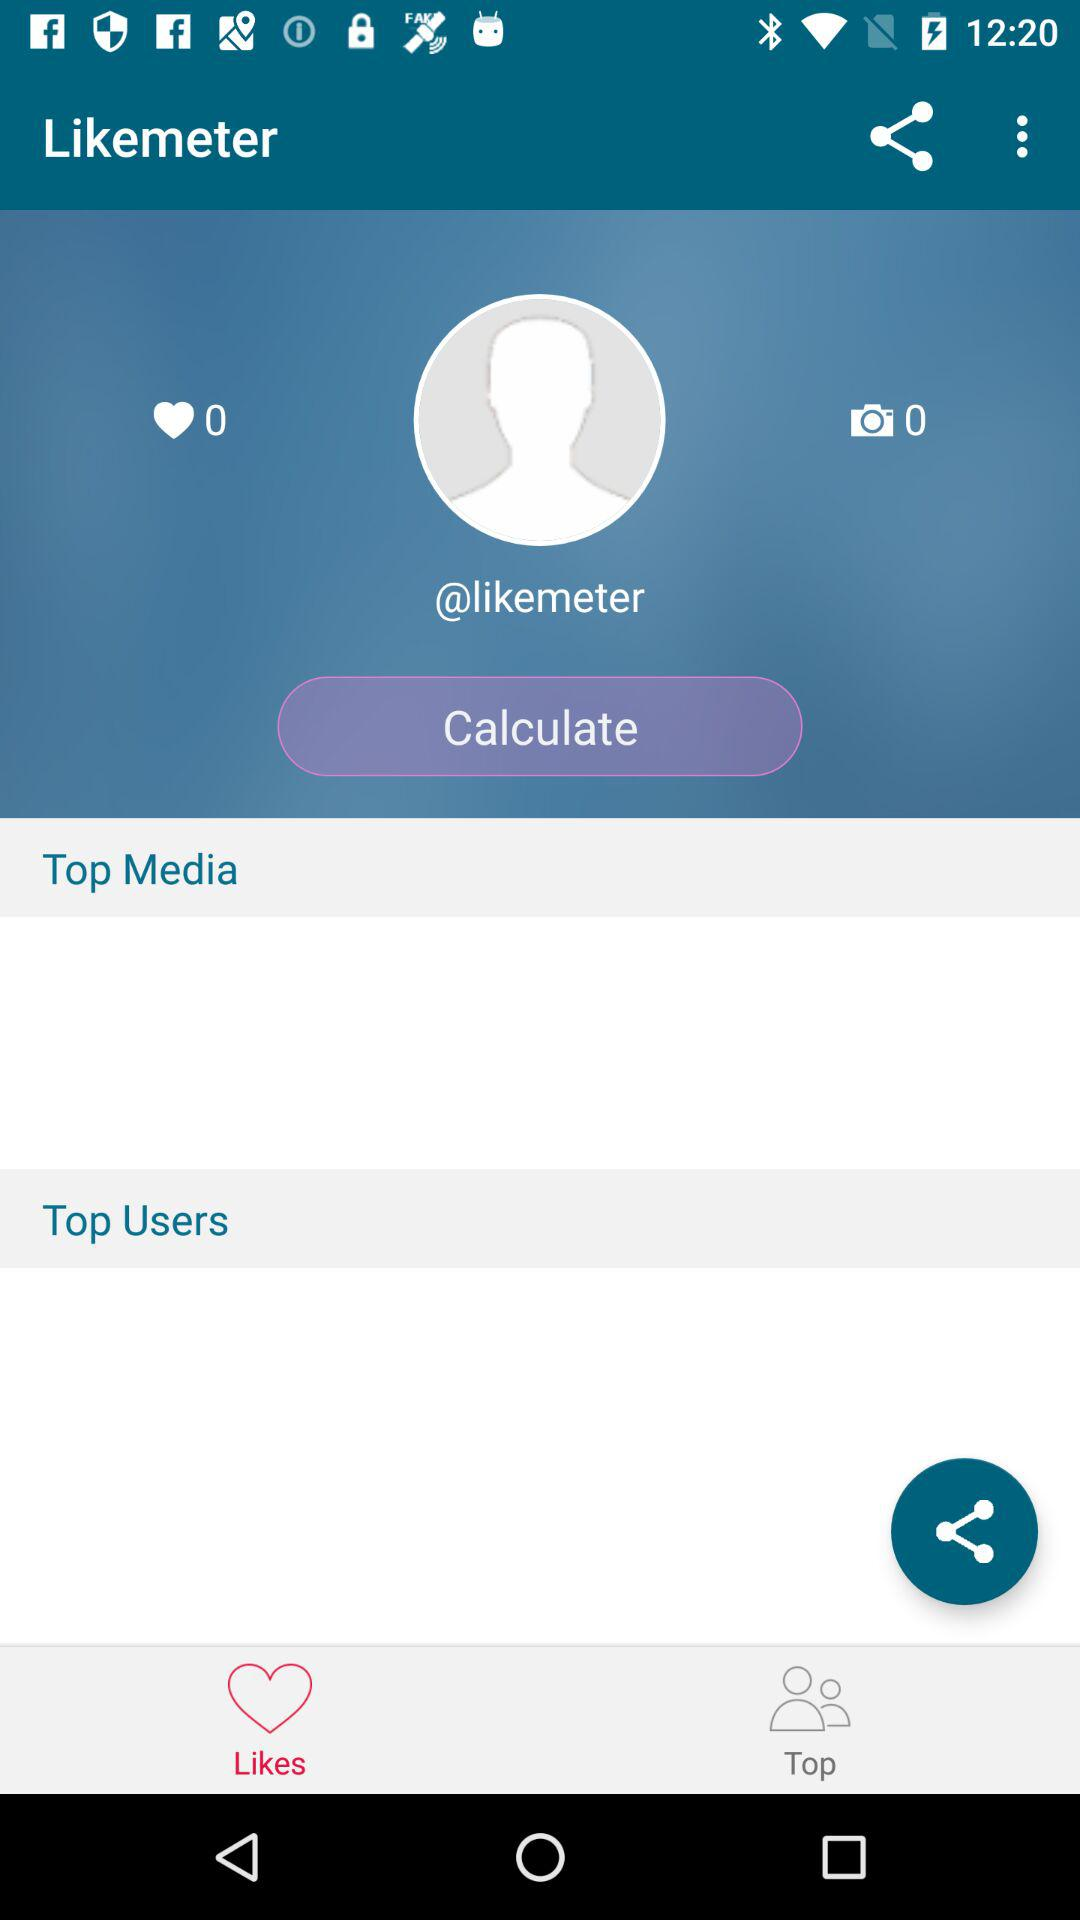How many images are there? There are 0 images. 